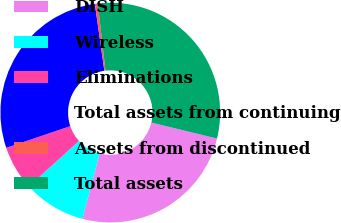<chart> <loc_0><loc_0><loc_500><loc_500><pie_chart><fcel>DISH<fcel>Wireless<fcel>Eliminations<fcel>Total assets from continuing<fcel>Assets from discontinued<fcel>Total assets<nl><fcel>25.28%<fcel>9.19%<fcel>6.53%<fcel>27.95%<fcel>0.43%<fcel>30.61%<nl></chart> 